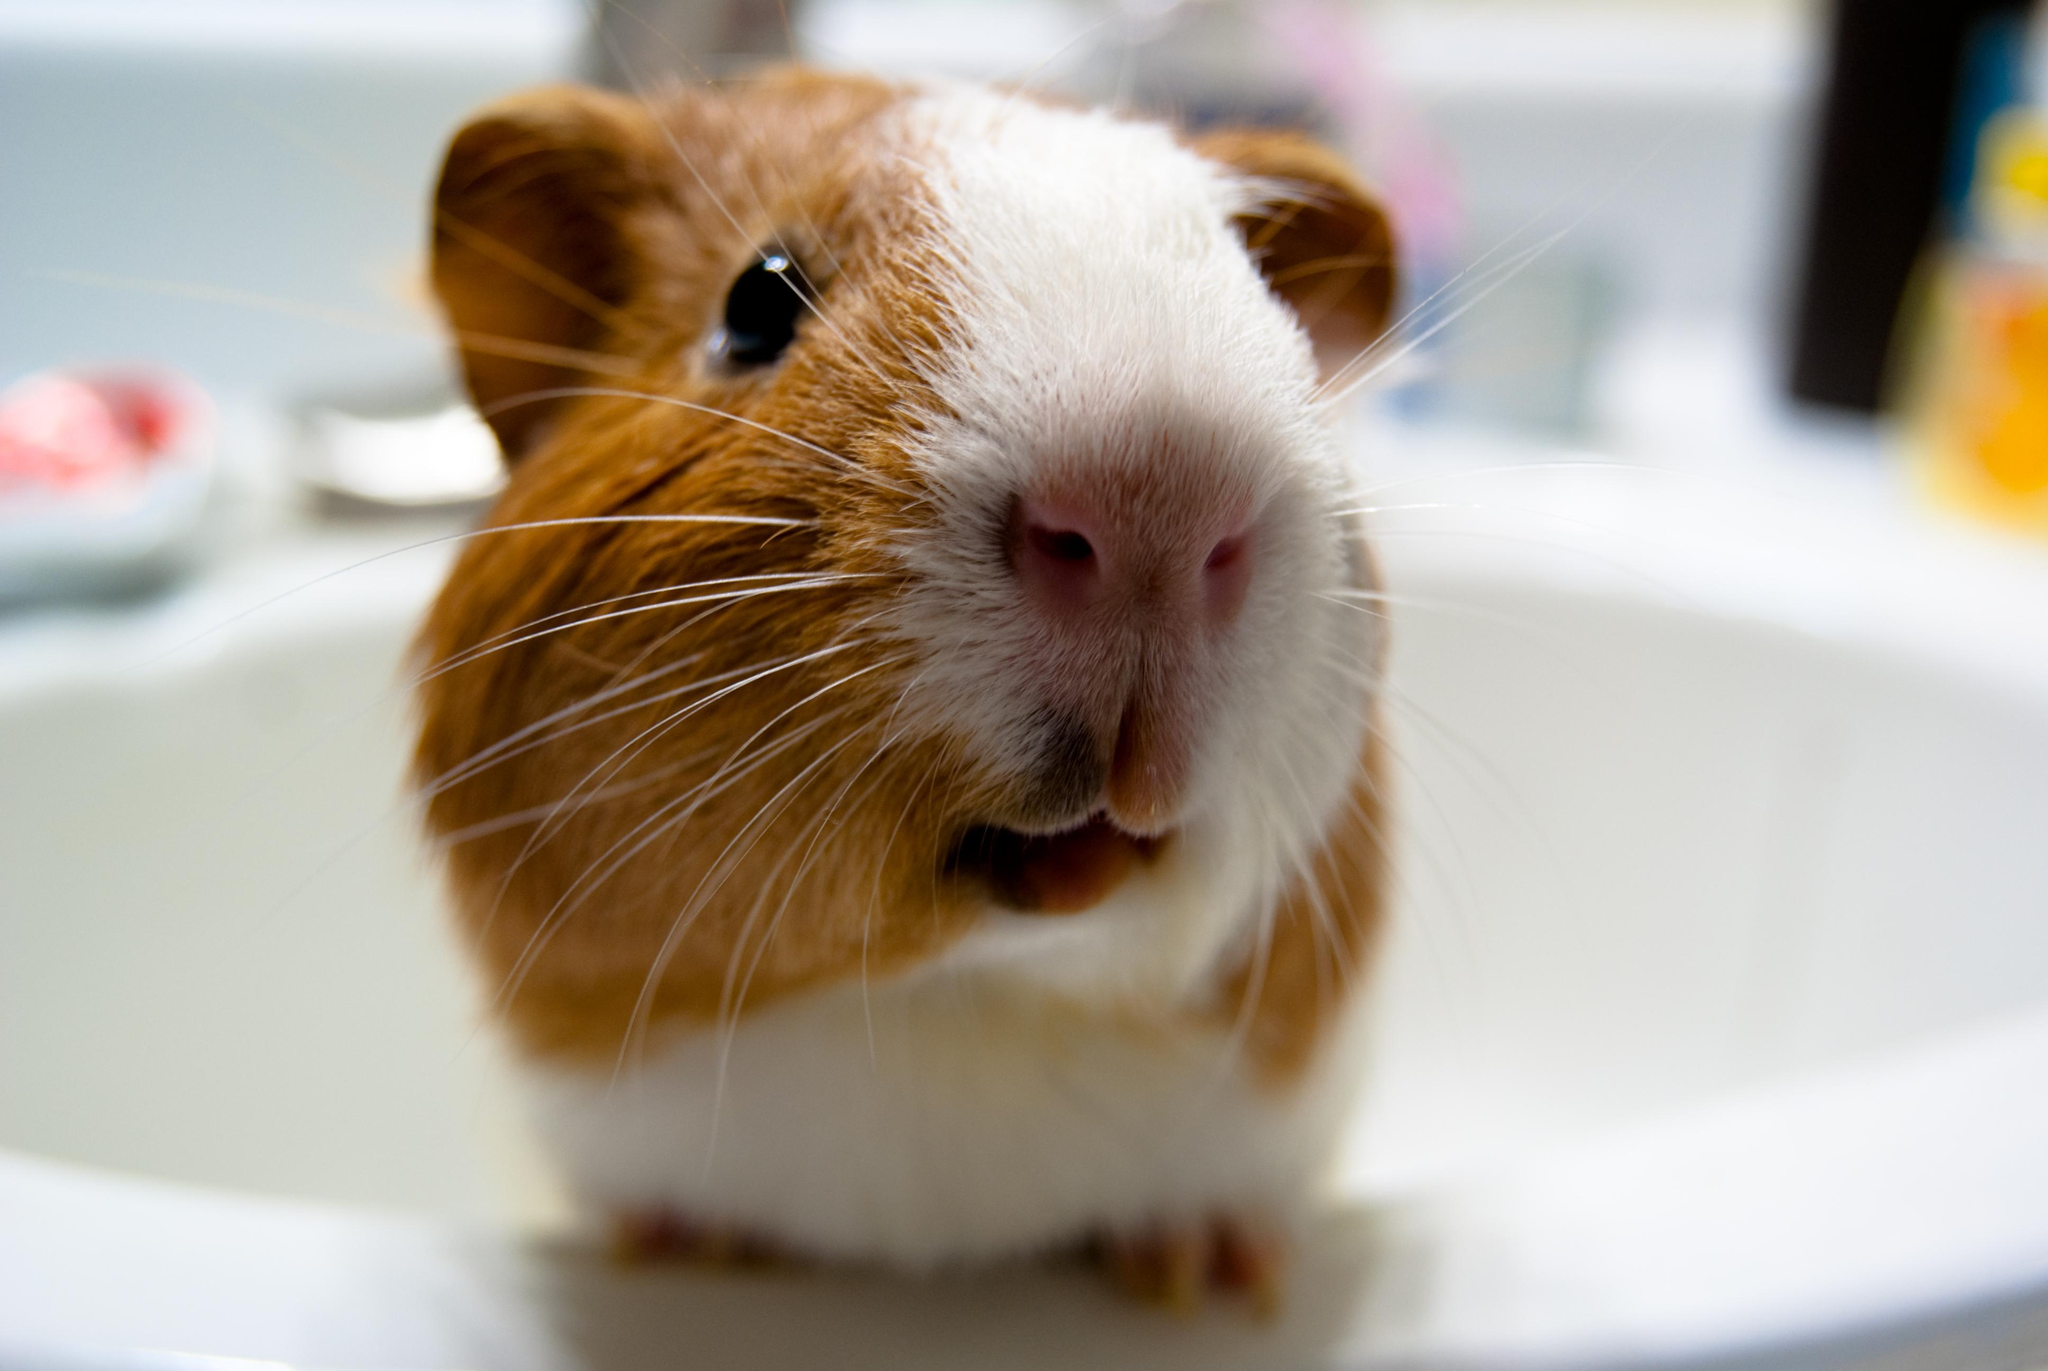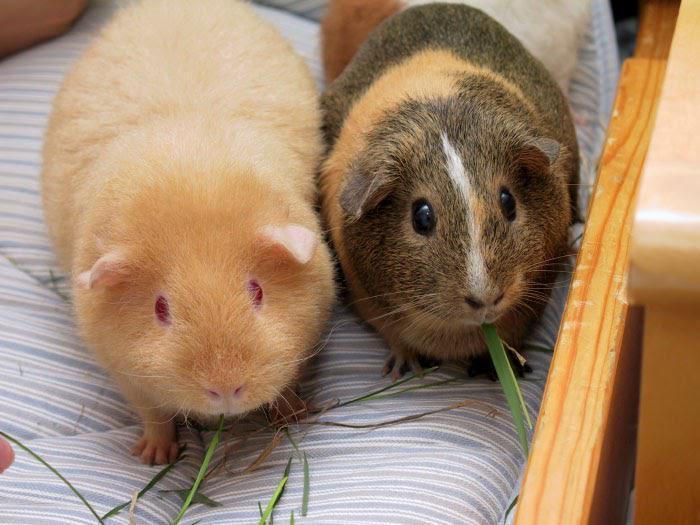The first image is the image on the left, the second image is the image on the right. Analyze the images presented: Is the assertion "There are two different guinea pigs featured here." valid? Answer yes or no. No. 